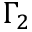Convert formula to latex. <formula><loc_0><loc_0><loc_500><loc_500>\Gamma _ { 2 }</formula> 